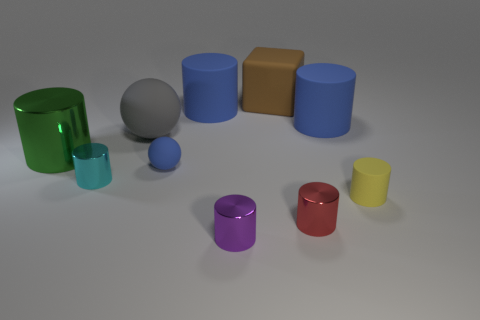Subtract all cyan cylinders. How many cylinders are left? 6 Subtract all rubber cylinders. How many cylinders are left? 4 Subtract all yellow cylinders. Subtract all green cubes. How many cylinders are left? 6 Subtract all blocks. How many objects are left? 9 Subtract 0 red blocks. How many objects are left? 10 Subtract all big gray matte balls. Subtract all blue matte balls. How many objects are left? 8 Add 9 large brown matte objects. How many large brown matte objects are left? 10 Add 4 large brown matte things. How many large brown matte things exist? 5 